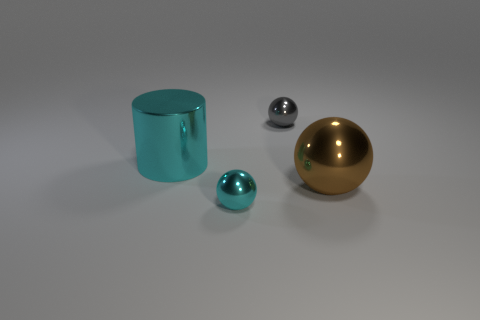Is the material of the large cyan cylinder the same as the brown sphere?
Provide a short and direct response. Yes. There is a tiny sphere that is in front of the cyan metallic cylinder; how many cyan metallic cylinders are in front of it?
Offer a very short reply. 0. Is there a large red metal object of the same shape as the tiny cyan object?
Provide a succinct answer. No. Does the metal object behind the large cyan object have the same shape as the large shiny object to the right of the big cyan metallic cylinder?
Provide a short and direct response. Yes. There is a thing that is both on the left side of the gray metal object and behind the cyan metallic ball; what is its shape?
Your answer should be very brief. Cylinder. Is there a cyan matte cube of the same size as the brown thing?
Provide a succinct answer. No. Does the cylinder have the same color as the tiny sphere behind the large brown shiny sphere?
Provide a short and direct response. No. What material is the large sphere?
Ensure brevity in your answer.  Metal. The small object that is behind the big cylinder is what color?
Your answer should be compact. Gray. How many big things are the same color as the metal cylinder?
Ensure brevity in your answer.  0. 